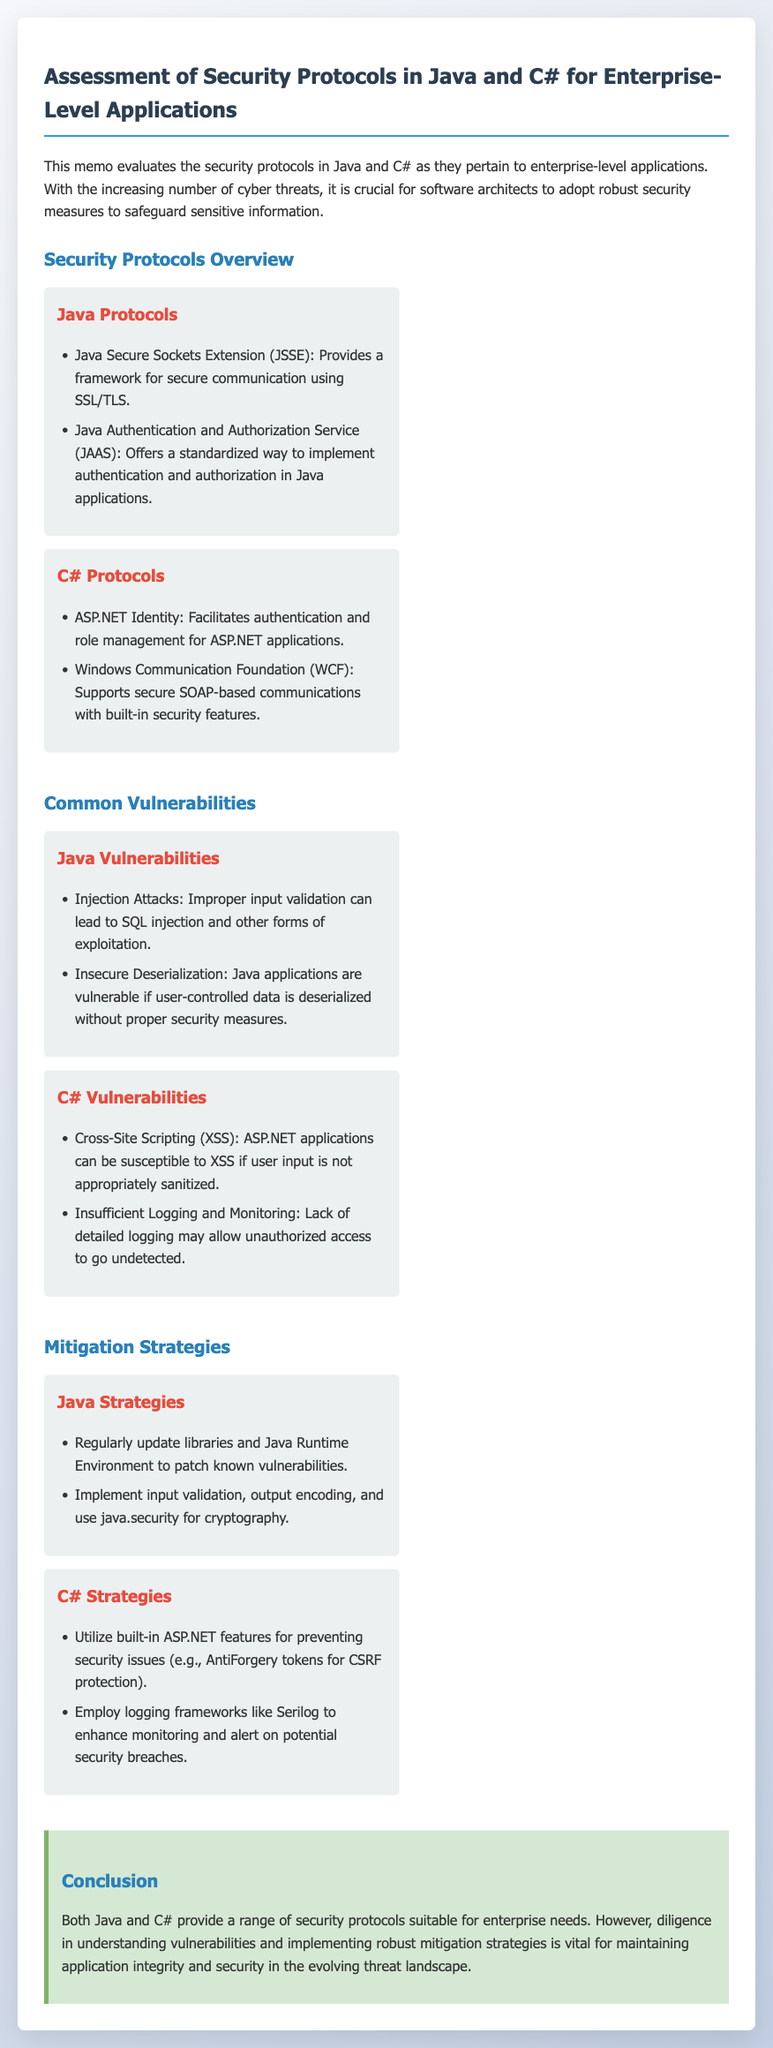what is the title of the memo? The title of the memo is stated at the beginning of the document, clearly outlined.
Answer: Assessment of Security Protocols in Java and C# for Enterprise-Level Applications name one Java security protocol mentioned in the document. The memo lists several protocols under Java security, and one example can be easily recalled from the text.
Answer: Java Secure Sockets Extension (JSSE) what is one common vulnerability in C# applications? The document outlines several vulnerabilities in relation to C#, and one specific vulnerability is directly stated.
Answer: Cross-Site Scripting (XSS) what is one mitigation strategy for Java applications? The document suggests various strategies to mitigate vulnerabilities, and one is specifically indicated.
Answer: Regularly update libraries and Java Runtime Environment how many Java vulnerabilities are listed in the document? The memo provides a specific number of vulnerabilities related to Java, which can be easily counted from the provided list.
Answer: Two which framework in C# facilitates authentication and role management? The document specifies a framework well-known for its role in C# security which can be easily identified.
Answer: ASP.NET Identity what is the main purpose of the memo? The memo states its objective clearly in the introductory paragraph, summarizing what it aims to achieve.
Answer: Evaluate the security protocols list one C# strategy for enhancing monitoring. The memo includes strategies for C# security, with one focused specifically on monitoring that stands out.
Answer: Employ logging frameworks like Serilog what section precedes the conclusion in the memo? The structure of the memo follows a specific order, and the section immediately before the conclusion is clearly marked.
Answer: Mitigation Strategies 